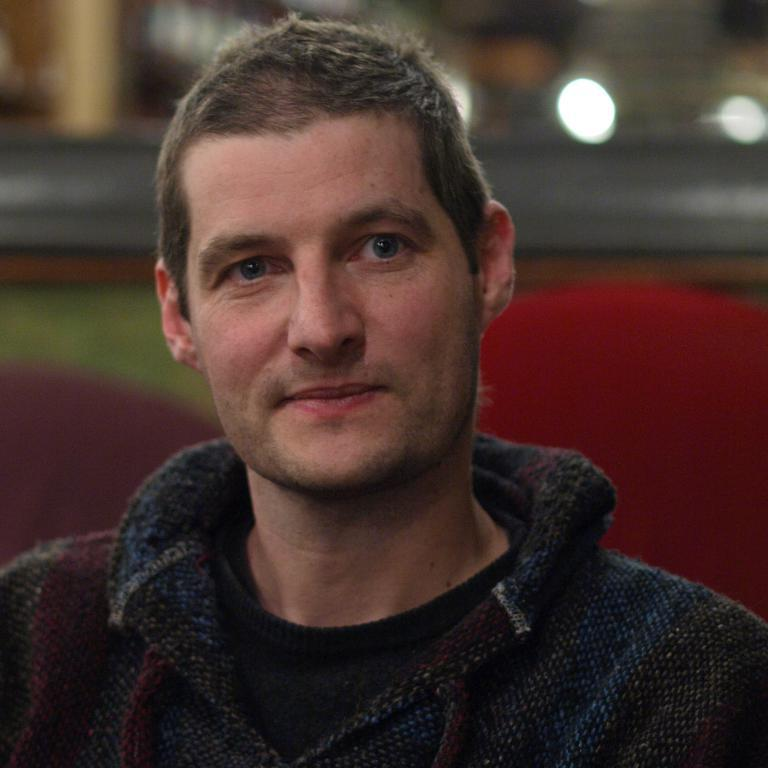Who or what is present in the image? There is a person in the image. What is the person's facial expression? The person is smiling. What is the person doing in the image? The person is watching something. Can you describe the background of the image? The background of the image is blurred. How many carriages are visible in the image? There are no carriages present in the image. What type of land can be seen in the background of the image? The background of the image is blurred, so it is not possible to determine the type of land in the image. 